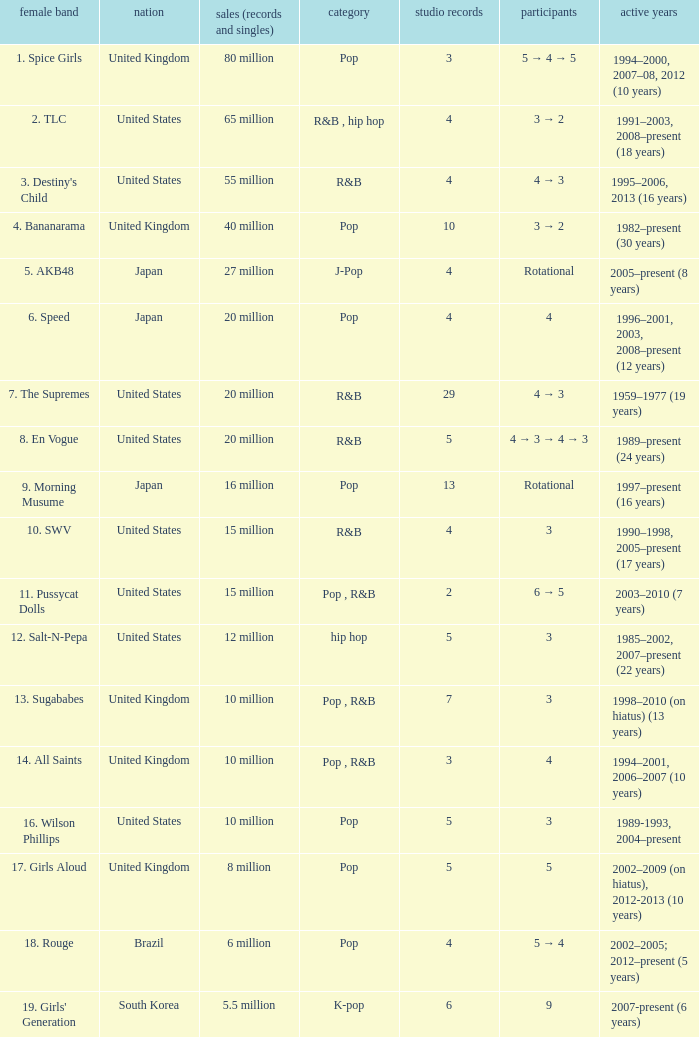What group had 29 studio albums? 7. The Supremes. 